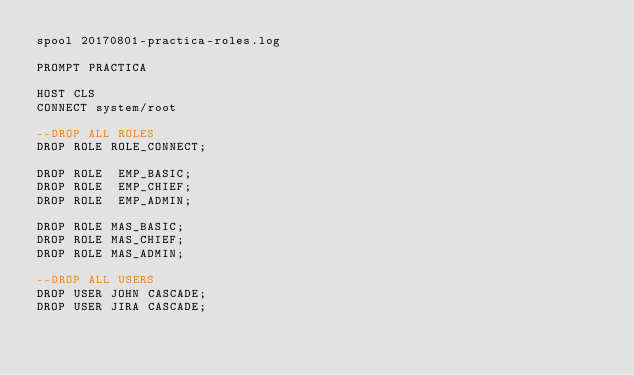<code> <loc_0><loc_0><loc_500><loc_500><_SQL_>spool 20170801-practica-roles.log

PROMPT PRACTICA

HOST CLS
CONNECT system/root

--DROP ALL ROLES
DROP ROLE ROLE_CONNECT;

DROP ROLE  EMP_BASIC;
DROP ROLE  EMP_CHIEF;
DROP ROLE  EMP_ADMIN;

DROP ROLE MAS_BASIC;
DROP ROLE MAS_CHIEF;
DROP ROLE MAS_ADMIN;

--DROP ALL USERS
DROP USER JOHN CASCADE;
DROP USER JIRA CASCADE;</code> 